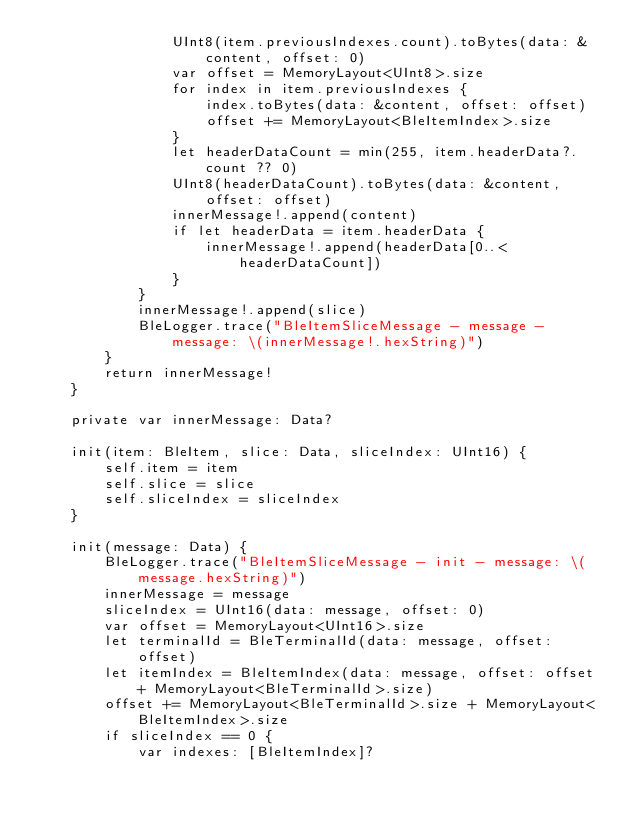<code> <loc_0><loc_0><loc_500><loc_500><_Swift_>                UInt8(item.previousIndexes.count).toBytes(data: &content, offset: 0)
                var offset = MemoryLayout<UInt8>.size
                for index in item.previousIndexes {
                    index.toBytes(data: &content, offset: offset)
                    offset += MemoryLayout<BleItemIndex>.size
                }
                let headerDataCount = min(255, item.headerData?.count ?? 0)
                UInt8(headerDataCount).toBytes(data: &content, offset: offset)
                innerMessage!.append(content)
                if let headerData = item.headerData {
                    innerMessage!.append(headerData[0..<headerDataCount])
                }
            }
            innerMessage!.append(slice)
            BleLogger.trace("BleItemSliceMessage - message - message: \(innerMessage!.hexString)")
        }
        return innerMessage!
    }
    
    private var innerMessage: Data?
    
    init(item: BleItem, slice: Data, sliceIndex: UInt16) {
        self.item = item
        self.slice = slice
        self.sliceIndex = sliceIndex
    }
    
    init(message: Data) {
        BleLogger.trace("BleItemSliceMessage - init - message: \(message.hexString)")
        innerMessage = message
        sliceIndex = UInt16(data: message, offset: 0)
        var offset = MemoryLayout<UInt16>.size
        let terminalId = BleTerminalId(data: message, offset: offset)
        let itemIndex = BleItemIndex(data: message, offset: offset + MemoryLayout<BleTerminalId>.size)
        offset += MemoryLayout<BleTerminalId>.size + MemoryLayout<BleItemIndex>.size
        if sliceIndex == 0 {
            var indexes: [BleItemIndex]?</code> 